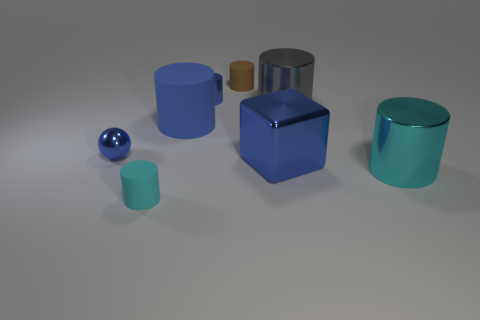The rubber object that is the same color as the small metal ball is what shape?
Offer a terse response. Cylinder. What number of things are small cylinders behind the tiny cyan cylinder or big blue things that are behind the tiny metal sphere?
Your answer should be very brief. 3. What is the size of the blue metallic object that is in front of the large matte object and left of the brown rubber cylinder?
Provide a succinct answer. Small. There is a large thing left of the blue block; is it the same shape as the brown matte thing?
Give a very brief answer. Yes. There is a cyan cylinder that is right of the tiny shiny object to the right of the tiny blue shiny ball on the left side of the small cyan matte cylinder; what size is it?
Your answer should be very brief. Large. What is the size of the rubber cylinder that is the same color as the sphere?
Give a very brief answer. Large. What number of objects are small blue spheres or green shiny blocks?
Make the answer very short. 1. The thing that is both left of the brown matte object and behind the gray cylinder has what shape?
Offer a terse response. Cylinder. There is a big blue metallic thing; is its shape the same as the rubber object behind the tiny blue metal cylinder?
Offer a terse response. No. Are there any large blue cubes behind the brown matte cylinder?
Provide a short and direct response. No. 